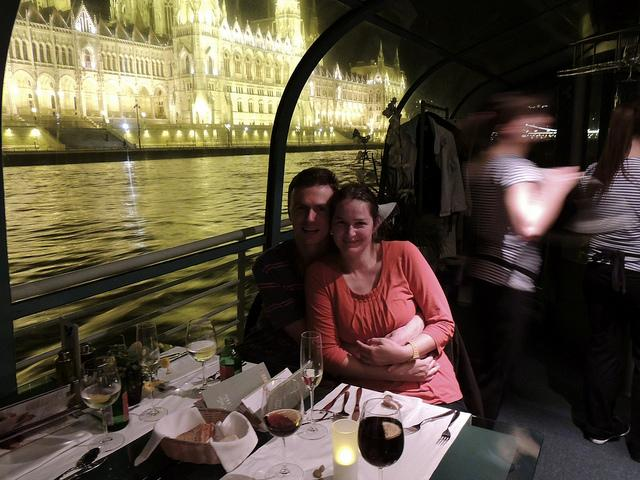Where is the couple most probably dining?

Choices:
A) home
B) restaurant
C) park
D) boat boat 